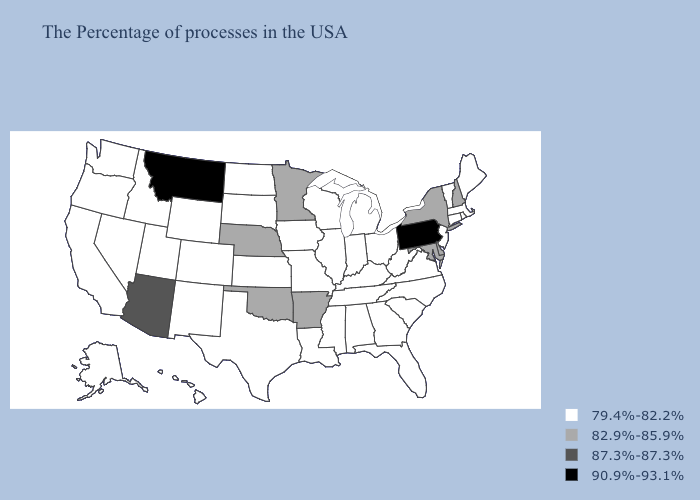Name the states that have a value in the range 87.3%-87.3%?
Write a very short answer. Arizona. Which states have the lowest value in the Northeast?
Keep it brief. Maine, Massachusetts, Rhode Island, Vermont, Connecticut, New Jersey. Does West Virginia have the same value as Delaware?
Give a very brief answer. No. Name the states that have a value in the range 82.9%-85.9%?
Keep it brief. New Hampshire, New York, Delaware, Maryland, Arkansas, Minnesota, Nebraska, Oklahoma. What is the value of Alabama?
Concise answer only. 79.4%-82.2%. What is the highest value in the West ?
Keep it brief. 90.9%-93.1%. Does Montana have the highest value in the USA?
Be succinct. Yes. What is the lowest value in the South?
Quick response, please. 79.4%-82.2%. Does Minnesota have a lower value than California?
Concise answer only. No. Does Montana have the lowest value in the West?
Be succinct. No. Does Louisiana have the lowest value in the USA?
Keep it brief. Yes. What is the lowest value in the USA?
Keep it brief. 79.4%-82.2%. What is the value of Indiana?
Short answer required. 79.4%-82.2%. 